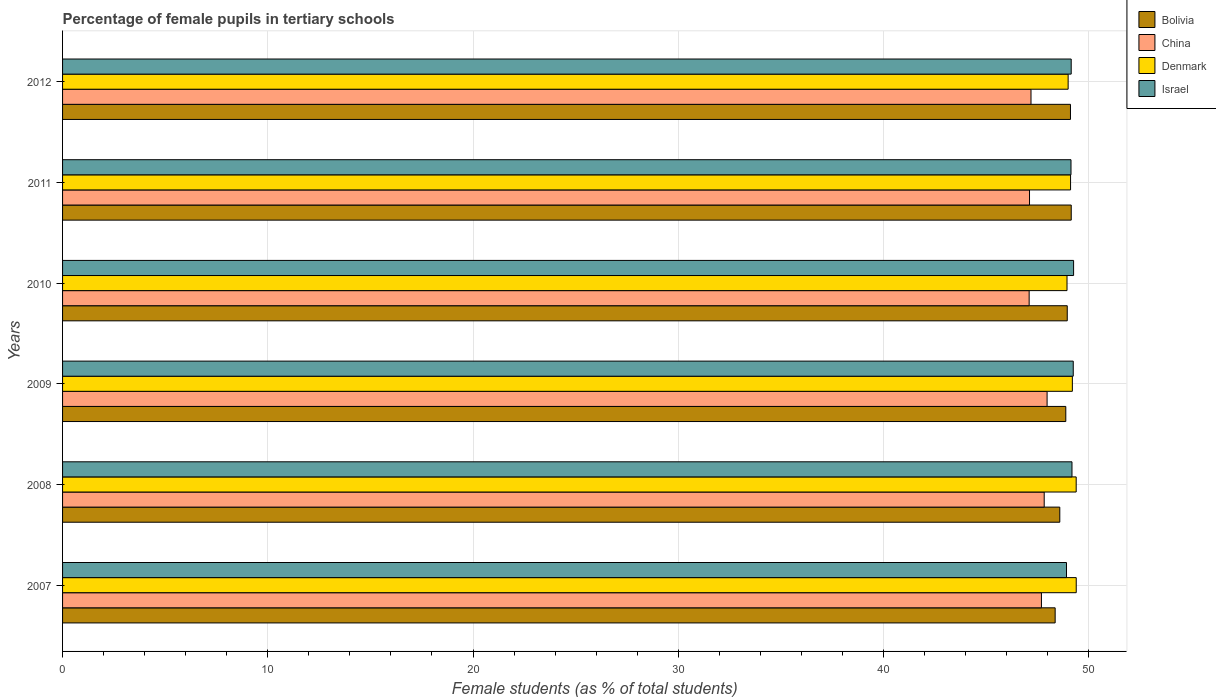How many different coloured bars are there?
Ensure brevity in your answer.  4. How many groups of bars are there?
Give a very brief answer. 6. Are the number of bars on each tick of the Y-axis equal?
Give a very brief answer. Yes. What is the label of the 6th group of bars from the top?
Provide a short and direct response. 2007. What is the percentage of female pupils in tertiary schools in China in 2008?
Your answer should be very brief. 47.83. Across all years, what is the maximum percentage of female pupils in tertiary schools in Denmark?
Your response must be concise. 49.39. Across all years, what is the minimum percentage of female pupils in tertiary schools in Bolivia?
Provide a short and direct response. 48.36. In which year was the percentage of female pupils in tertiary schools in Bolivia minimum?
Offer a very short reply. 2007. What is the total percentage of female pupils in tertiary schools in China in the graph?
Keep it short and to the point. 284.9. What is the difference between the percentage of female pupils in tertiary schools in Israel in 2009 and that in 2010?
Make the answer very short. -0.02. What is the difference between the percentage of female pupils in tertiary schools in China in 2009 and the percentage of female pupils in tertiary schools in Denmark in 2007?
Give a very brief answer. -1.42. What is the average percentage of female pupils in tertiary schools in China per year?
Provide a succinct answer. 47.48. In the year 2009, what is the difference between the percentage of female pupils in tertiary schools in Bolivia and percentage of female pupils in tertiary schools in Denmark?
Your response must be concise. -0.32. What is the ratio of the percentage of female pupils in tertiary schools in China in 2007 to that in 2008?
Keep it short and to the point. 1. Is the percentage of female pupils in tertiary schools in Israel in 2009 less than that in 2012?
Your answer should be very brief. No. Is the difference between the percentage of female pupils in tertiary schools in Bolivia in 2009 and 2010 greater than the difference between the percentage of female pupils in tertiary schools in Denmark in 2009 and 2010?
Offer a terse response. No. What is the difference between the highest and the second highest percentage of female pupils in tertiary schools in China?
Give a very brief answer. 0.14. What is the difference between the highest and the lowest percentage of female pupils in tertiary schools in Israel?
Keep it short and to the point. 0.35. In how many years, is the percentage of female pupils in tertiary schools in Israel greater than the average percentage of female pupils in tertiary schools in Israel taken over all years?
Provide a short and direct response. 3. Is the sum of the percentage of female pupils in tertiary schools in Bolivia in 2008 and 2009 greater than the maximum percentage of female pupils in tertiary schools in Denmark across all years?
Provide a succinct answer. Yes. Is it the case that in every year, the sum of the percentage of female pupils in tertiary schools in Denmark and percentage of female pupils in tertiary schools in China is greater than the sum of percentage of female pupils in tertiary schools in Bolivia and percentage of female pupils in tertiary schools in Israel?
Ensure brevity in your answer.  No. How many years are there in the graph?
Make the answer very short. 6. What is the difference between two consecutive major ticks on the X-axis?
Offer a terse response. 10. Are the values on the major ticks of X-axis written in scientific E-notation?
Your response must be concise. No. Does the graph contain grids?
Your answer should be very brief. Yes. How are the legend labels stacked?
Provide a succinct answer. Vertical. What is the title of the graph?
Ensure brevity in your answer.  Percentage of female pupils in tertiary schools. Does "Barbados" appear as one of the legend labels in the graph?
Your answer should be compact. No. What is the label or title of the X-axis?
Your answer should be very brief. Female students (as % of total students). What is the label or title of the Y-axis?
Your answer should be very brief. Years. What is the Female students (as % of total students) of Bolivia in 2007?
Your answer should be very brief. 48.36. What is the Female students (as % of total students) in China in 2007?
Offer a terse response. 47.7. What is the Female students (as % of total students) of Denmark in 2007?
Offer a terse response. 49.39. What is the Female students (as % of total students) of Israel in 2007?
Offer a very short reply. 48.92. What is the Female students (as % of total students) in Bolivia in 2008?
Your response must be concise. 48.59. What is the Female students (as % of total students) of China in 2008?
Ensure brevity in your answer.  47.83. What is the Female students (as % of total students) of Denmark in 2008?
Your answer should be compact. 49.39. What is the Female students (as % of total students) in Israel in 2008?
Your answer should be compact. 49.18. What is the Female students (as % of total students) in Bolivia in 2009?
Your response must be concise. 48.88. What is the Female students (as % of total students) in China in 2009?
Provide a succinct answer. 47.97. What is the Female students (as % of total students) in Denmark in 2009?
Offer a terse response. 49.2. What is the Female students (as % of total students) of Israel in 2009?
Give a very brief answer. 49.25. What is the Female students (as % of total students) in Bolivia in 2010?
Your answer should be very brief. 48.95. What is the Female students (as % of total students) in China in 2010?
Offer a terse response. 47.1. What is the Female students (as % of total students) of Denmark in 2010?
Give a very brief answer. 48.94. What is the Female students (as % of total students) of Israel in 2010?
Give a very brief answer. 49.26. What is the Female students (as % of total students) of Bolivia in 2011?
Your response must be concise. 49.15. What is the Female students (as % of total students) in China in 2011?
Your answer should be very brief. 47.11. What is the Female students (as % of total students) in Denmark in 2011?
Make the answer very short. 49.11. What is the Female students (as % of total students) in Israel in 2011?
Keep it short and to the point. 49.14. What is the Female students (as % of total students) in Bolivia in 2012?
Make the answer very short. 49.11. What is the Female students (as % of total students) in China in 2012?
Make the answer very short. 47.19. What is the Female students (as % of total students) in Denmark in 2012?
Provide a succinct answer. 49. What is the Female students (as % of total students) of Israel in 2012?
Your answer should be compact. 49.15. Across all years, what is the maximum Female students (as % of total students) in Bolivia?
Your response must be concise. 49.15. Across all years, what is the maximum Female students (as % of total students) of China?
Keep it short and to the point. 47.97. Across all years, what is the maximum Female students (as % of total students) of Denmark?
Your answer should be very brief. 49.39. Across all years, what is the maximum Female students (as % of total students) in Israel?
Make the answer very short. 49.26. Across all years, what is the minimum Female students (as % of total students) of Bolivia?
Make the answer very short. 48.36. Across all years, what is the minimum Female students (as % of total students) of China?
Keep it short and to the point. 47.1. Across all years, what is the minimum Female students (as % of total students) in Denmark?
Ensure brevity in your answer.  48.94. Across all years, what is the minimum Female students (as % of total students) in Israel?
Give a very brief answer. 48.92. What is the total Female students (as % of total students) of Bolivia in the graph?
Provide a succinct answer. 293.05. What is the total Female students (as % of total students) in China in the graph?
Your response must be concise. 284.9. What is the total Female students (as % of total students) of Denmark in the graph?
Give a very brief answer. 295.04. What is the total Female students (as % of total students) in Israel in the graph?
Offer a terse response. 294.89. What is the difference between the Female students (as % of total students) in Bolivia in 2007 and that in 2008?
Offer a very short reply. -0.23. What is the difference between the Female students (as % of total students) in China in 2007 and that in 2008?
Your answer should be compact. -0.13. What is the difference between the Female students (as % of total students) in Denmark in 2007 and that in 2008?
Your answer should be very brief. 0. What is the difference between the Female students (as % of total students) of Israel in 2007 and that in 2008?
Offer a terse response. -0.27. What is the difference between the Female students (as % of total students) of Bolivia in 2007 and that in 2009?
Offer a very short reply. -0.52. What is the difference between the Female students (as % of total students) of China in 2007 and that in 2009?
Provide a succinct answer. -0.28. What is the difference between the Female students (as % of total students) in Denmark in 2007 and that in 2009?
Offer a terse response. 0.19. What is the difference between the Female students (as % of total students) in Israel in 2007 and that in 2009?
Provide a succinct answer. -0.33. What is the difference between the Female students (as % of total students) in Bolivia in 2007 and that in 2010?
Your response must be concise. -0.59. What is the difference between the Female students (as % of total students) of China in 2007 and that in 2010?
Make the answer very short. 0.6. What is the difference between the Female students (as % of total students) in Denmark in 2007 and that in 2010?
Your answer should be very brief. 0.45. What is the difference between the Female students (as % of total students) in Israel in 2007 and that in 2010?
Your answer should be compact. -0.35. What is the difference between the Female students (as % of total students) in Bolivia in 2007 and that in 2011?
Your answer should be very brief. -0.78. What is the difference between the Female students (as % of total students) of China in 2007 and that in 2011?
Provide a short and direct response. 0.58. What is the difference between the Female students (as % of total students) in Denmark in 2007 and that in 2011?
Keep it short and to the point. 0.28. What is the difference between the Female students (as % of total students) of Israel in 2007 and that in 2011?
Give a very brief answer. -0.22. What is the difference between the Female students (as % of total students) of Bolivia in 2007 and that in 2012?
Provide a succinct answer. -0.75. What is the difference between the Female students (as % of total students) in China in 2007 and that in 2012?
Offer a terse response. 0.51. What is the difference between the Female students (as % of total students) of Denmark in 2007 and that in 2012?
Give a very brief answer. 0.39. What is the difference between the Female students (as % of total students) in Israel in 2007 and that in 2012?
Keep it short and to the point. -0.23. What is the difference between the Female students (as % of total students) of Bolivia in 2008 and that in 2009?
Offer a terse response. -0.29. What is the difference between the Female students (as % of total students) of China in 2008 and that in 2009?
Ensure brevity in your answer.  -0.14. What is the difference between the Female students (as % of total students) of Denmark in 2008 and that in 2009?
Keep it short and to the point. 0.19. What is the difference between the Female students (as % of total students) of Israel in 2008 and that in 2009?
Give a very brief answer. -0.06. What is the difference between the Female students (as % of total students) in Bolivia in 2008 and that in 2010?
Your answer should be compact. -0.36. What is the difference between the Female students (as % of total students) of China in 2008 and that in 2010?
Keep it short and to the point. 0.73. What is the difference between the Female students (as % of total students) of Denmark in 2008 and that in 2010?
Give a very brief answer. 0.45. What is the difference between the Female students (as % of total students) in Israel in 2008 and that in 2010?
Give a very brief answer. -0.08. What is the difference between the Female students (as % of total students) of Bolivia in 2008 and that in 2011?
Your answer should be compact. -0.56. What is the difference between the Female students (as % of total students) in China in 2008 and that in 2011?
Offer a very short reply. 0.72. What is the difference between the Female students (as % of total students) in Denmark in 2008 and that in 2011?
Your answer should be very brief. 0.27. What is the difference between the Female students (as % of total students) in Israel in 2008 and that in 2011?
Your response must be concise. 0.05. What is the difference between the Female students (as % of total students) of Bolivia in 2008 and that in 2012?
Offer a very short reply. -0.52. What is the difference between the Female students (as % of total students) of China in 2008 and that in 2012?
Make the answer very short. 0.64. What is the difference between the Female students (as % of total students) in Denmark in 2008 and that in 2012?
Your answer should be compact. 0.39. What is the difference between the Female students (as % of total students) of Israel in 2008 and that in 2012?
Provide a succinct answer. 0.04. What is the difference between the Female students (as % of total students) in Bolivia in 2009 and that in 2010?
Keep it short and to the point. -0.07. What is the difference between the Female students (as % of total students) in China in 2009 and that in 2010?
Provide a short and direct response. 0.87. What is the difference between the Female students (as % of total students) in Denmark in 2009 and that in 2010?
Your answer should be compact. 0.26. What is the difference between the Female students (as % of total students) of Israel in 2009 and that in 2010?
Your answer should be very brief. -0.02. What is the difference between the Female students (as % of total students) in Bolivia in 2009 and that in 2011?
Your answer should be compact. -0.26. What is the difference between the Female students (as % of total students) in China in 2009 and that in 2011?
Ensure brevity in your answer.  0.86. What is the difference between the Female students (as % of total students) of Denmark in 2009 and that in 2011?
Provide a short and direct response. 0.09. What is the difference between the Female students (as % of total students) of Israel in 2009 and that in 2011?
Offer a terse response. 0.11. What is the difference between the Female students (as % of total students) of Bolivia in 2009 and that in 2012?
Provide a succinct answer. -0.23. What is the difference between the Female students (as % of total students) in China in 2009 and that in 2012?
Provide a succinct answer. 0.78. What is the difference between the Female students (as % of total students) in Denmark in 2009 and that in 2012?
Provide a short and direct response. 0.21. What is the difference between the Female students (as % of total students) of Israel in 2009 and that in 2012?
Offer a terse response. 0.1. What is the difference between the Female students (as % of total students) of Bolivia in 2010 and that in 2011?
Give a very brief answer. -0.19. What is the difference between the Female students (as % of total students) in China in 2010 and that in 2011?
Give a very brief answer. -0.02. What is the difference between the Female students (as % of total students) in Denmark in 2010 and that in 2011?
Provide a short and direct response. -0.17. What is the difference between the Female students (as % of total students) of Israel in 2010 and that in 2011?
Your answer should be compact. 0.13. What is the difference between the Female students (as % of total students) in Bolivia in 2010 and that in 2012?
Offer a terse response. -0.16. What is the difference between the Female students (as % of total students) in China in 2010 and that in 2012?
Offer a terse response. -0.09. What is the difference between the Female students (as % of total students) of Denmark in 2010 and that in 2012?
Provide a succinct answer. -0.06. What is the difference between the Female students (as % of total students) in Israel in 2010 and that in 2012?
Give a very brief answer. 0.12. What is the difference between the Female students (as % of total students) in Bolivia in 2011 and that in 2012?
Provide a succinct answer. 0.04. What is the difference between the Female students (as % of total students) in China in 2011 and that in 2012?
Offer a terse response. -0.07. What is the difference between the Female students (as % of total students) in Denmark in 2011 and that in 2012?
Your answer should be compact. 0.12. What is the difference between the Female students (as % of total students) of Israel in 2011 and that in 2012?
Ensure brevity in your answer.  -0.01. What is the difference between the Female students (as % of total students) of Bolivia in 2007 and the Female students (as % of total students) of China in 2008?
Offer a very short reply. 0.53. What is the difference between the Female students (as % of total students) of Bolivia in 2007 and the Female students (as % of total students) of Denmark in 2008?
Your answer should be compact. -1.02. What is the difference between the Female students (as % of total students) in Bolivia in 2007 and the Female students (as % of total students) in Israel in 2008?
Your answer should be very brief. -0.82. What is the difference between the Female students (as % of total students) of China in 2007 and the Female students (as % of total students) of Denmark in 2008?
Give a very brief answer. -1.69. What is the difference between the Female students (as % of total students) in China in 2007 and the Female students (as % of total students) in Israel in 2008?
Your answer should be very brief. -1.49. What is the difference between the Female students (as % of total students) of Denmark in 2007 and the Female students (as % of total students) of Israel in 2008?
Provide a short and direct response. 0.21. What is the difference between the Female students (as % of total students) of Bolivia in 2007 and the Female students (as % of total students) of China in 2009?
Provide a short and direct response. 0.39. What is the difference between the Female students (as % of total students) in Bolivia in 2007 and the Female students (as % of total students) in Denmark in 2009?
Give a very brief answer. -0.84. What is the difference between the Female students (as % of total students) in Bolivia in 2007 and the Female students (as % of total students) in Israel in 2009?
Offer a very short reply. -0.88. What is the difference between the Female students (as % of total students) of China in 2007 and the Female students (as % of total students) of Denmark in 2009?
Offer a terse response. -1.51. What is the difference between the Female students (as % of total students) in China in 2007 and the Female students (as % of total students) in Israel in 2009?
Ensure brevity in your answer.  -1.55. What is the difference between the Female students (as % of total students) in Denmark in 2007 and the Female students (as % of total students) in Israel in 2009?
Your answer should be compact. 0.15. What is the difference between the Female students (as % of total students) in Bolivia in 2007 and the Female students (as % of total students) in China in 2010?
Your response must be concise. 1.27. What is the difference between the Female students (as % of total students) of Bolivia in 2007 and the Female students (as % of total students) of Denmark in 2010?
Keep it short and to the point. -0.58. What is the difference between the Female students (as % of total students) of Bolivia in 2007 and the Female students (as % of total students) of Israel in 2010?
Offer a terse response. -0.9. What is the difference between the Female students (as % of total students) of China in 2007 and the Female students (as % of total students) of Denmark in 2010?
Offer a terse response. -1.25. What is the difference between the Female students (as % of total students) of China in 2007 and the Female students (as % of total students) of Israel in 2010?
Keep it short and to the point. -1.57. What is the difference between the Female students (as % of total students) in Denmark in 2007 and the Female students (as % of total students) in Israel in 2010?
Provide a short and direct response. 0.13. What is the difference between the Female students (as % of total students) of Bolivia in 2007 and the Female students (as % of total students) of China in 2011?
Offer a terse response. 1.25. What is the difference between the Female students (as % of total students) of Bolivia in 2007 and the Female students (as % of total students) of Denmark in 2011?
Offer a very short reply. -0.75. What is the difference between the Female students (as % of total students) in Bolivia in 2007 and the Female students (as % of total students) in Israel in 2011?
Provide a short and direct response. -0.77. What is the difference between the Female students (as % of total students) of China in 2007 and the Female students (as % of total students) of Denmark in 2011?
Make the answer very short. -1.42. What is the difference between the Female students (as % of total students) of China in 2007 and the Female students (as % of total students) of Israel in 2011?
Keep it short and to the point. -1.44. What is the difference between the Female students (as % of total students) of Denmark in 2007 and the Female students (as % of total students) of Israel in 2011?
Offer a very short reply. 0.26. What is the difference between the Female students (as % of total students) of Bolivia in 2007 and the Female students (as % of total students) of China in 2012?
Ensure brevity in your answer.  1.18. What is the difference between the Female students (as % of total students) of Bolivia in 2007 and the Female students (as % of total students) of Denmark in 2012?
Your response must be concise. -0.63. What is the difference between the Female students (as % of total students) in Bolivia in 2007 and the Female students (as % of total students) in Israel in 2012?
Keep it short and to the point. -0.78. What is the difference between the Female students (as % of total students) in China in 2007 and the Female students (as % of total students) in Denmark in 2012?
Your answer should be compact. -1.3. What is the difference between the Female students (as % of total students) of China in 2007 and the Female students (as % of total students) of Israel in 2012?
Offer a very short reply. -1.45. What is the difference between the Female students (as % of total students) in Denmark in 2007 and the Female students (as % of total students) in Israel in 2012?
Give a very brief answer. 0.24. What is the difference between the Female students (as % of total students) in Bolivia in 2008 and the Female students (as % of total students) in China in 2009?
Ensure brevity in your answer.  0.62. What is the difference between the Female students (as % of total students) of Bolivia in 2008 and the Female students (as % of total students) of Denmark in 2009?
Your answer should be very brief. -0.61. What is the difference between the Female students (as % of total students) in Bolivia in 2008 and the Female students (as % of total students) in Israel in 2009?
Keep it short and to the point. -0.66. What is the difference between the Female students (as % of total students) in China in 2008 and the Female students (as % of total students) in Denmark in 2009?
Provide a succinct answer. -1.37. What is the difference between the Female students (as % of total students) in China in 2008 and the Female students (as % of total students) in Israel in 2009?
Offer a very short reply. -1.42. What is the difference between the Female students (as % of total students) of Denmark in 2008 and the Female students (as % of total students) of Israel in 2009?
Your answer should be very brief. 0.14. What is the difference between the Female students (as % of total students) of Bolivia in 2008 and the Female students (as % of total students) of China in 2010?
Your answer should be compact. 1.49. What is the difference between the Female students (as % of total students) of Bolivia in 2008 and the Female students (as % of total students) of Denmark in 2010?
Ensure brevity in your answer.  -0.35. What is the difference between the Female students (as % of total students) in Bolivia in 2008 and the Female students (as % of total students) in Israel in 2010?
Keep it short and to the point. -0.67. What is the difference between the Female students (as % of total students) of China in 2008 and the Female students (as % of total students) of Denmark in 2010?
Ensure brevity in your answer.  -1.11. What is the difference between the Female students (as % of total students) in China in 2008 and the Female students (as % of total students) in Israel in 2010?
Provide a succinct answer. -1.43. What is the difference between the Female students (as % of total students) in Denmark in 2008 and the Female students (as % of total students) in Israel in 2010?
Provide a succinct answer. 0.13. What is the difference between the Female students (as % of total students) of Bolivia in 2008 and the Female students (as % of total students) of China in 2011?
Keep it short and to the point. 1.48. What is the difference between the Female students (as % of total students) of Bolivia in 2008 and the Female students (as % of total students) of Denmark in 2011?
Give a very brief answer. -0.52. What is the difference between the Female students (as % of total students) in Bolivia in 2008 and the Female students (as % of total students) in Israel in 2011?
Ensure brevity in your answer.  -0.55. What is the difference between the Female students (as % of total students) of China in 2008 and the Female students (as % of total students) of Denmark in 2011?
Give a very brief answer. -1.28. What is the difference between the Female students (as % of total students) of China in 2008 and the Female students (as % of total students) of Israel in 2011?
Your response must be concise. -1.31. What is the difference between the Female students (as % of total students) in Denmark in 2008 and the Female students (as % of total students) in Israel in 2011?
Your answer should be compact. 0.25. What is the difference between the Female students (as % of total students) of Bolivia in 2008 and the Female students (as % of total students) of China in 2012?
Provide a succinct answer. 1.4. What is the difference between the Female students (as % of total students) of Bolivia in 2008 and the Female students (as % of total students) of Denmark in 2012?
Offer a very short reply. -0.41. What is the difference between the Female students (as % of total students) in Bolivia in 2008 and the Female students (as % of total students) in Israel in 2012?
Provide a short and direct response. -0.56. What is the difference between the Female students (as % of total students) in China in 2008 and the Female students (as % of total students) in Denmark in 2012?
Your answer should be very brief. -1.17. What is the difference between the Female students (as % of total students) of China in 2008 and the Female students (as % of total students) of Israel in 2012?
Offer a very short reply. -1.32. What is the difference between the Female students (as % of total students) in Denmark in 2008 and the Female students (as % of total students) in Israel in 2012?
Your response must be concise. 0.24. What is the difference between the Female students (as % of total students) of Bolivia in 2009 and the Female students (as % of total students) of China in 2010?
Offer a very short reply. 1.79. What is the difference between the Female students (as % of total students) in Bolivia in 2009 and the Female students (as % of total students) in Denmark in 2010?
Provide a succinct answer. -0.06. What is the difference between the Female students (as % of total students) of Bolivia in 2009 and the Female students (as % of total students) of Israel in 2010?
Offer a very short reply. -0.38. What is the difference between the Female students (as % of total students) in China in 2009 and the Female students (as % of total students) in Denmark in 2010?
Provide a succinct answer. -0.97. What is the difference between the Female students (as % of total students) of China in 2009 and the Female students (as % of total students) of Israel in 2010?
Provide a succinct answer. -1.29. What is the difference between the Female students (as % of total students) of Denmark in 2009 and the Female students (as % of total students) of Israel in 2010?
Ensure brevity in your answer.  -0.06. What is the difference between the Female students (as % of total students) of Bolivia in 2009 and the Female students (as % of total students) of China in 2011?
Offer a very short reply. 1.77. What is the difference between the Female students (as % of total students) of Bolivia in 2009 and the Female students (as % of total students) of Denmark in 2011?
Ensure brevity in your answer.  -0.23. What is the difference between the Female students (as % of total students) of Bolivia in 2009 and the Female students (as % of total students) of Israel in 2011?
Your response must be concise. -0.25. What is the difference between the Female students (as % of total students) in China in 2009 and the Female students (as % of total students) in Denmark in 2011?
Provide a short and direct response. -1.14. What is the difference between the Female students (as % of total students) of China in 2009 and the Female students (as % of total students) of Israel in 2011?
Offer a terse response. -1.16. What is the difference between the Female students (as % of total students) in Denmark in 2009 and the Female students (as % of total students) in Israel in 2011?
Ensure brevity in your answer.  0.07. What is the difference between the Female students (as % of total students) in Bolivia in 2009 and the Female students (as % of total students) in China in 2012?
Your answer should be compact. 1.7. What is the difference between the Female students (as % of total students) in Bolivia in 2009 and the Female students (as % of total students) in Denmark in 2012?
Give a very brief answer. -0.11. What is the difference between the Female students (as % of total students) of Bolivia in 2009 and the Female students (as % of total students) of Israel in 2012?
Provide a short and direct response. -0.26. What is the difference between the Female students (as % of total students) of China in 2009 and the Female students (as % of total students) of Denmark in 2012?
Your answer should be very brief. -1.03. What is the difference between the Female students (as % of total students) in China in 2009 and the Female students (as % of total students) in Israel in 2012?
Your response must be concise. -1.17. What is the difference between the Female students (as % of total students) in Denmark in 2009 and the Female students (as % of total students) in Israel in 2012?
Your response must be concise. 0.06. What is the difference between the Female students (as % of total students) of Bolivia in 2010 and the Female students (as % of total students) of China in 2011?
Provide a short and direct response. 1.84. What is the difference between the Female students (as % of total students) in Bolivia in 2010 and the Female students (as % of total students) in Denmark in 2011?
Your response must be concise. -0.16. What is the difference between the Female students (as % of total students) in Bolivia in 2010 and the Female students (as % of total students) in Israel in 2011?
Provide a succinct answer. -0.18. What is the difference between the Female students (as % of total students) in China in 2010 and the Female students (as % of total students) in Denmark in 2011?
Ensure brevity in your answer.  -2.02. What is the difference between the Female students (as % of total students) of China in 2010 and the Female students (as % of total students) of Israel in 2011?
Offer a very short reply. -2.04. What is the difference between the Female students (as % of total students) of Denmark in 2010 and the Female students (as % of total students) of Israel in 2011?
Your response must be concise. -0.19. What is the difference between the Female students (as % of total students) in Bolivia in 2010 and the Female students (as % of total students) in China in 2012?
Keep it short and to the point. 1.77. What is the difference between the Female students (as % of total students) of Bolivia in 2010 and the Female students (as % of total students) of Denmark in 2012?
Your answer should be compact. -0.04. What is the difference between the Female students (as % of total students) of Bolivia in 2010 and the Female students (as % of total students) of Israel in 2012?
Provide a succinct answer. -0.19. What is the difference between the Female students (as % of total students) of China in 2010 and the Female students (as % of total students) of Denmark in 2012?
Your answer should be very brief. -1.9. What is the difference between the Female students (as % of total students) in China in 2010 and the Female students (as % of total students) in Israel in 2012?
Offer a very short reply. -2.05. What is the difference between the Female students (as % of total students) in Denmark in 2010 and the Female students (as % of total students) in Israel in 2012?
Offer a very short reply. -0.2. What is the difference between the Female students (as % of total students) in Bolivia in 2011 and the Female students (as % of total students) in China in 2012?
Your answer should be compact. 1.96. What is the difference between the Female students (as % of total students) of Bolivia in 2011 and the Female students (as % of total students) of Denmark in 2012?
Your answer should be compact. 0.15. What is the difference between the Female students (as % of total students) of Bolivia in 2011 and the Female students (as % of total students) of Israel in 2012?
Provide a succinct answer. 0. What is the difference between the Female students (as % of total students) in China in 2011 and the Female students (as % of total students) in Denmark in 2012?
Your answer should be very brief. -1.88. What is the difference between the Female students (as % of total students) in China in 2011 and the Female students (as % of total students) in Israel in 2012?
Ensure brevity in your answer.  -2.03. What is the difference between the Female students (as % of total students) in Denmark in 2011 and the Female students (as % of total students) in Israel in 2012?
Provide a succinct answer. -0.03. What is the average Female students (as % of total students) in Bolivia per year?
Offer a terse response. 48.84. What is the average Female students (as % of total students) in China per year?
Keep it short and to the point. 47.48. What is the average Female students (as % of total students) of Denmark per year?
Give a very brief answer. 49.17. What is the average Female students (as % of total students) in Israel per year?
Ensure brevity in your answer.  49.15. In the year 2007, what is the difference between the Female students (as % of total students) of Bolivia and Female students (as % of total students) of China?
Ensure brevity in your answer.  0.67. In the year 2007, what is the difference between the Female students (as % of total students) of Bolivia and Female students (as % of total students) of Denmark?
Provide a succinct answer. -1.03. In the year 2007, what is the difference between the Female students (as % of total students) of Bolivia and Female students (as % of total students) of Israel?
Keep it short and to the point. -0.55. In the year 2007, what is the difference between the Female students (as % of total students) in China and Female students (as % of total students) in Denmark?
Ensure brevity in your answer.  -1.7. In the year 2007, what is the difference between the Female students (as % of total students) in China and Female students (as % of total students) in Israel?
Provide a short and direct response. -1.22. In the year 2007, what is the difference between the Female students (as % of total students) of Denmark and Female students (as % of total students) of Israel?
Your answer should be very brief. 0.47. In the year 2008, what is the difference between the Female students (as % of total students) of Bolivia and Female students (as % of total students) of China?
Ensure brevity in your answer.  0.76. In the year 2008, what is the difference between the Female students (as % of total students) in Bolivia and Female students (as % of total students) in Denmark?
Keep it short and to the point. -0.8. In the year 2008, what is the difference between the Female students (as % of total students) of Bolivia and Female students (as % of total students) of Israel?
Your answer should be very brief. -0.59. In the year 2008, what is the difference between the Female students (as % of total students) in China and Female students (as % of total students) in Denmark?
Your answer should be very brief. -1.56. In the year 2008, what is the difference between the Female students (as % of total students) of China and Female students (as % of total students) of Israel?
Keep it short and to the point. -1.35. In the year 2008, what is the difference between the Female students (as % of total students) of Denmark and Female students (as % of total students) of Israel?
Give a very brief answer. 0.2. In the year 2009, what is the difference between the Female students (as % of total students) of Bolivia and Female students (as % of total students) of China?
Offer a terse response. 0.91. In the year 2009, what is the difference between the Female students (as % of total students) of Bolivia and Female students (as % of total students) of Denmark?
Provide a short and direct response. -0.32. In the year 2009, what is the difference between the Female students (as % of total students) of Bolivia and Female students (as % of total students) of Israel?
Keep it short and to the point. -0.36. In the year 2009, what is the difference between the Female students (as % of total students) of China and Female students (as % of total students) of Denmark?
Provide a succinct answer. -1.23. In the year 2009, what is the difference between the Female students (as % of total students) of China and Female students (as % of total students) of Israel?
Provide a succinct answer. -1.27. In the year 2009, what is the difference between the Female students (as % of total students) in Denmark and Female students (as % of total students) in Israel?
Your response must be concise. -0.04. In the year 2010, what is the difference between the Female students (as % of total students) of Bolivia and Female students (as % of total students) of China?
Provide a short and direct response. 1.86. In the year 2010, what is the difference between the Female students (as % of total students) in Bolivia and Female students (as % of total students) in Denmark?
Provide a short and direct response. 0.01. In the year 2010, what is the difference between the Female students (as % of total students) in Bolivia and Female students (as % of total students) in Israel?
Keep it short and to the point. -0.31. In the year 2010, what is the difference between the Female students (as % of total students) of China and Female students (as % of total students) of Denmark?
Offer a very short reply. -1.84. In the year 2010, what is the difference between the Female students (as % of total students) in China and Female students (as % of total students) in Israel?
Your answer should be very brief. -2.17. In the year 2010, what is the difference between the Female students (as % of total students) in Denmark and Female students (as % of total students) in Israel?
Provide a succinct answer. -0.32. In the year 2011, what is the difference between the Female students (as % of total students) in Bolivia and Female students (as % of total students) in China?
Your response must be concise. 2.03. In the year 2011, what is the difference between the Female students (as % of total students) in Bolivia and Female students (as % of total students) in Denmark?
Keep it short and to the point. 0.03. In the year 2011, what is the difference between the Female students (as % of total students) in Bolivia and Female students (as % of total students) in Israel?
Keep it short and to the point. 0.01. In the year 2011, what is the difference between the Female students (as % of total students) of China and Female students (as % of total students) of Denmark?
Your answer should be compact. -2. In the year 2011, what is the difference between the Female students (as % of total students) of China and Female students (as % of total students) of Israel?
Your response must be concise. -2.02. In the year 2011, what is the difference between the Female students (as % of total students) of Denmark and Female students (as % of total students) of Israel?
Offer a very short reply. -0.02. In the year 2012, what is the difference between the Female students (as % of total students) in Bolivia and Female students (as % of total students) in China?
Your answer should be compact. 1.92. In the year 2012, what is the difference between the Female students (as % of total students) of Bolivia and Female students (as % of total students) of Denmark?
Keep it short and to the point. 0.11. In the year 2012, what is the difference between the Female students (as % of total students) in Bolivia and Female students (as % of total students) in Israel?
Keep it short and to the point. -0.04. In the year 2012, what is the difference between the Female students (as % of total students) in China and Female students (as % of total students) in Denmark?
Your response must be concise. -1.81. In the year 2012, what is the difference between the Female students (as % of total students) of China and Female students (as % of total students) of Israel?
Give a very brief answer. -1.96. In the year 2012, what is the difference between the Female students (as % of total students) of Denmark and Female students (as % of total students) of Israel?
Offer a very short reply. -0.15. What is the ratio of the Female students (as % of total students) in Bolivia in 2007 to that in 2008?
Your response must be concise. 1. What is the ratio of the Female students (as % of total students) in China in 2007 to that in 2008?
Ensure brevity in your answer.  1. What is the ratio of the Female students (as % of total students) in Bolivia in 2007 to that in 2009?
Provide a succinct answer. 0.99. What is the ratio of the Female students (as % of total students) of Israel in 2007 to that in 2009?
Provide a succinct answer. 0.99. What is the ratio of the Female students (as % of total students) of Bolivia in 2007 to that in 2010?
Offer a very short reply. 0.99. What is the ratio of the Female students (as % of total students) of China in 2007 to that in 2010?
Ensure brevity in your answer.  1.01. What is the ratio of the Female students (as % of total students) of Denmark in 2007 to that in 2010?
Keep it short and to the point. 1.01. What is the ratio of the Female students (as % of total students) in Bolivia in 2007 to that in 2011?
Offer a terse response. 0.98. What is the ratio of the Female students (as % of total students) of China in 2007 to that in 2011?
Keep it short and to the point. 1.01. What is the ratio of the Female students (as % of total students) in Denmark in 2007 to that in 2011?
Offer a very short reply. 1.01. What is the ratio of the Female students (as % of total students) of Israel in 2007 to that in 2011?
Your response must be concise. 1. What is the ratio of the Female students (as % of total students) of China in 2007 to that in 2012?
Offer a terse response. 1.01. What is the ratio of the Female students (as % of total students) in China in 2008 to that in 2009?
Your answer should be compact. 1. What is the ratio of the Female students (as % of total students) in Bolivia in 2008 to that in 2010?
Make the answer very short. 0.99. What is the ratio of the Female students (as % of total students) of China in 2008 to that in 2010?
Offer a very short reply. 1.02. What is the ratio of the Female students (as % of total students) in Denmark in 2008 to that in 2010?
Give a very brief answer. 1.01. What is the ratio of the Female students (as % of total students) of Israel in 2008 to that in 2010?
Make the answer very short. 1. What is the ratio of the Female students (as % of total students) in Bolivia in 2008 to that in 2011?
Your answer should be compact. 0.99. What is the ratio of the Female students (as % of total students) in China in 2008 to that in 2011?
Provide a short and direct response. 1.02. What is the ratio of the Female students (as % of total students) of Denmark in 2008 to that in 2011?
Keep it short and to the point. 1.01. What is the ratio of the Female students (as % of total students) of Israel in 2008 to that in 2011?
Give a very brief answer. 1. What is the ratio of the Female students (as % of total students) of China in 2008 to that in 2012?
Give a very brief answer. 1.01. What is the ratio of the Female students (as % of total students) of Denmark in 2008 to that in 2012?
Offer a very short reply. 1.01. What is the ratio of the Female students (as % of total students) of Israel in 2008 to that in 2012?
Your response must be concise. 1. What is the ratio of the Female students (as % of total students) in Bolivia in 2009 to that in 2010?
Your response must be concise. 1. What is the ratio of the Female students (as % of total students) of China in 2009 to that in 2010?
Provide a short and direct response. 1.02. What is the ratio of the Female students (as % of total students) of Israel in 2009 to that in 2010?
Ensure brevity in your answer.  1. What is the ratio of the Female students (as % of total students) of Bolivia in 2009 to that in 2011?
Offer a very short reply. 0.99. What is the ratio of the Female students (as % of total students) in China in 2009 to that in 2011?
Ensure brevity in your answer.  1.02. What is the ratio of the Female students (as % of total students) in Denmark in 2009 to that in 2011?
Offer a terse response. 1. What is the ratio of the Female students (as % of total students) of Israel in 2009 to that in 2011?
Keep it short and to the point. 1. What is the ratio of the Female students (as % of total students) in China in 2009 to that in 2012?
Your response must be concise. 1.02. What is the ratio of the Female students (as % of total students) in Israel in 2009 to that in 2012?
Make the answer very short. 1. What is the ratio of the Female students (as % of total students) in Bolivia in 2010 to that in 2011?
Your answer should be very brief. 1. What is the ratio of the Female students (as % of total students) in China in 2010 to that in 2011?
Keep it short and to the point. 1. What is the ratio of the Female students (as % of total students) of Israel in 2010 to that in 2011?
Your answer should be compact. 1. What is the ratio of the Female students (as % of total students) in Bolivia in 2010 to that in 2012?
Ensure brevity in your answer.  1. What is the ratio of the Female students (as % of total students) of China in 2010 to that in 2012?
Ensure brevity in your answer.  1. What is the ratio of the Female students (as % of total students) in Denmark in 2011 to that in 2012?
Your answer should be compact. 1. What is the ratio of the Female students (as % of total students) in Israel in 2011 to that in 2012?
Ensure brevity in your answer.  1. What is the difference between the highest and the second highest Female students (as % of total students) of Bolivia?
Ensure brevity in your answer.  0.04. What is the difference between the highest and the second highest Female students (as % of total students) in China?
Offer a very short reply. 0.14. What is the difference between the highest and the second highest Female students (as % of total students) of Denmark?
Provide a succinct answer. 0. What is the difference between the highest and the second highest Female students (as % of total students) of Israel?
Provide a short and direct response. 0.02. What is the difference between the highest and the lowest Female students (as % of total students) in Bolivia?
Provide a short and direct response. 0.78. What is the difference between the highest and the lowest Female students (as % of total students) in China?
Offer a terse response. 0.87. What is the difference between the highest and the lowest Female students (as % of total students) of Denmark?
Your response must be concise. 0.45. What is the difference between the highest and the lowest Female students (as % of total students) of Israel?
Ensure brevity in your answer.  0.35. 